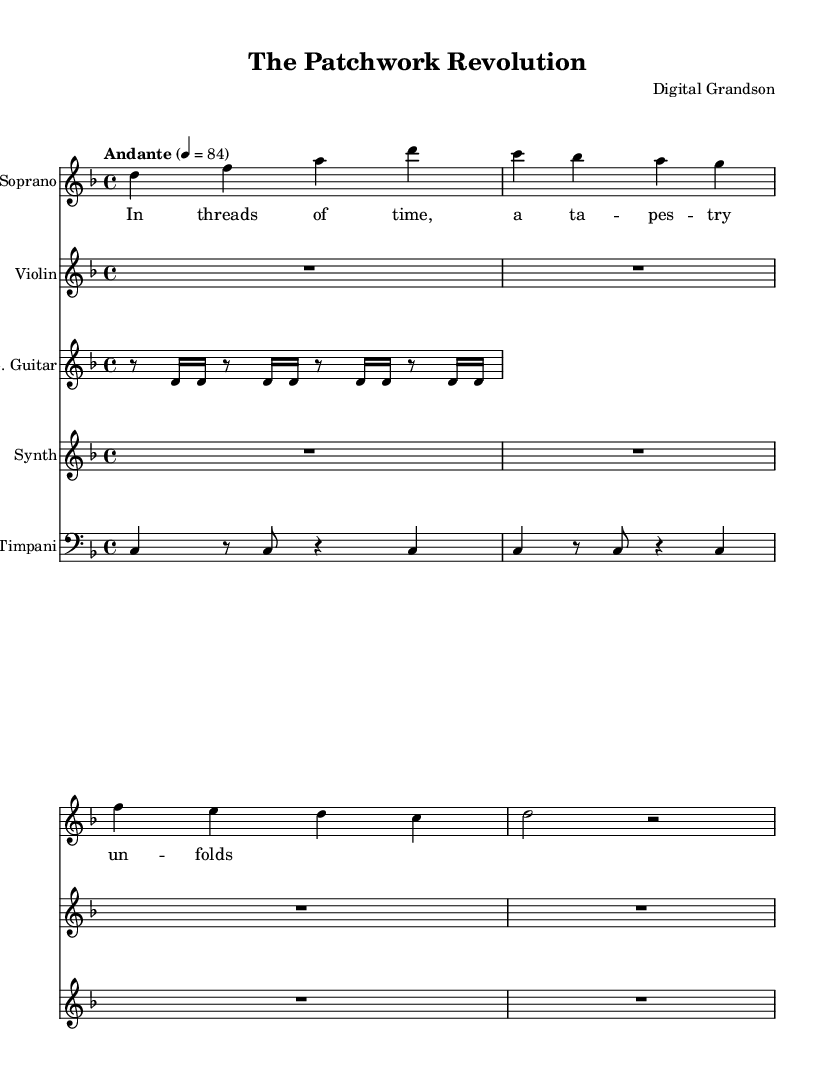What is the key signature of this music? The key signature is D minor, indicated by the presence of one flat (B flat) in the key signature at the beginning of the staff.
Answer: D minor What is the time signature of this music? The time signature is 4/4, shown near the beginning of the score, indicating four beats per measure with the quarter note getting one beat.
Answer: 4/4 What is the tempo marking for this piece? The tempo marking is "Andante" with a metronome marking of 84, suggesting a moderately slow pace. This is indicated at the top of the score.
Answer: Andante How many instruments are involved in the piece? There are five instruments mentioned in the score: Soprano, Violin, Electric Guitar, Synth, and Timpani. Each has its own staff indicating separate instrumental parts.
Answer: Five What is the first note of the Soprano voice? The first note of the Soprano voice is D, which can be identified at the beginning of the Soprano staff.
Answer: D What lyric corresponds to the first measure of the Soprano voice? The lyric corresponding to the first measure of the Soprano voice is "In," which is placed beneath the first note D in the Soprano staff.
Answer: In How long does the Timpani part hold the first note? The Timpani part holds the first note for four beats, indicated by the whole note "c4" with a quarter note time duration in the score.
Answer: Four beats 